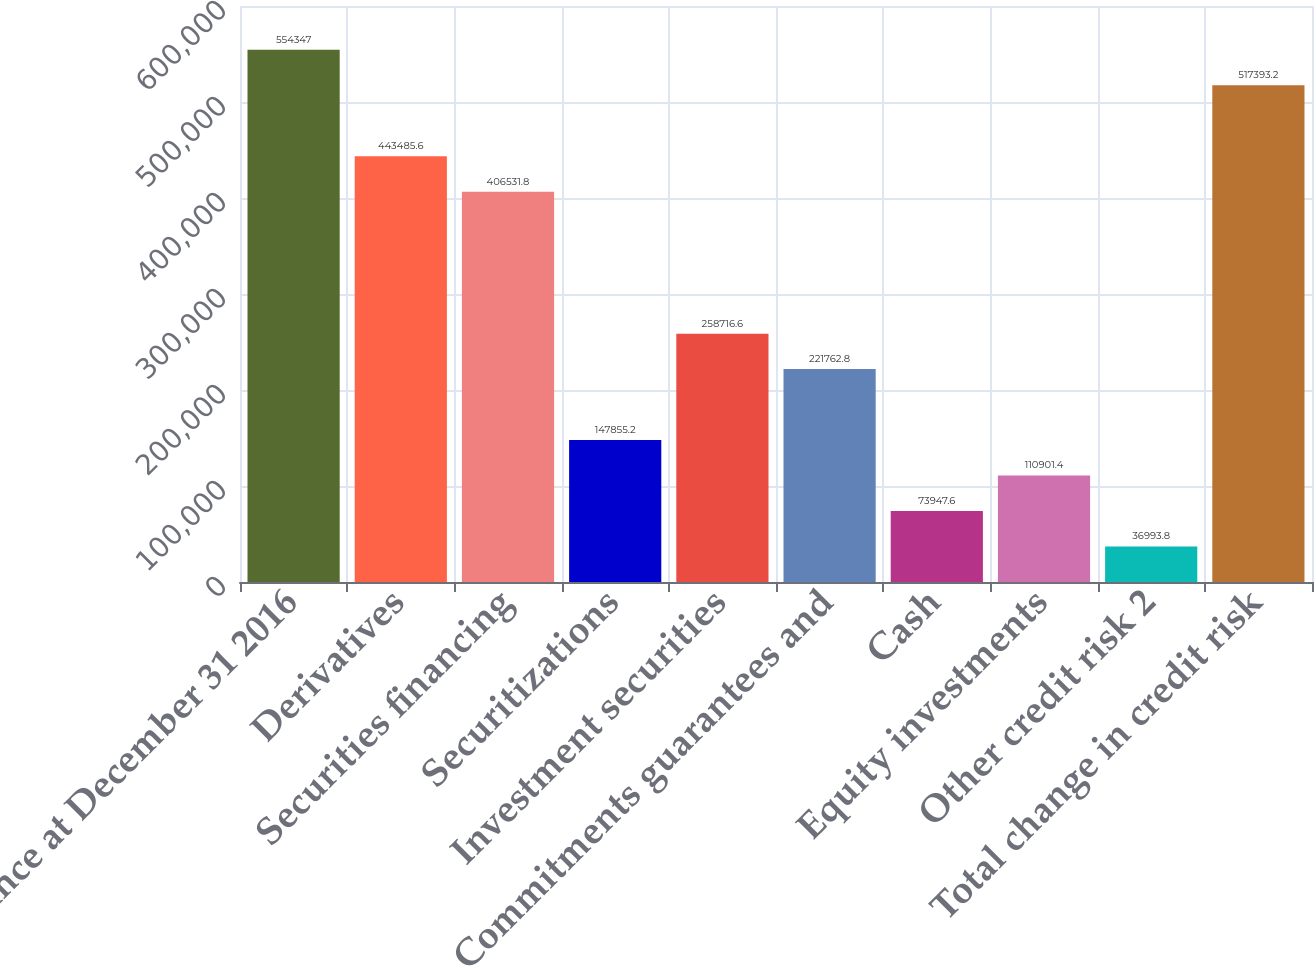Convert chart to OTSL. <chart><loc_0><loc_0><loc_500><loc_500><bar_chart><fcel>Balance at December 31 2016<fcel>Derivatives<fcel>Securities financing<fcel>Securitizations<fcel>Investment securities<fcel>Commitments guarantees and<fcel>Cash<fcel>Equity investments<fcel>Other credit risk 2<fcel>Total change in credit risk<nl><fcel>554347<fcel>443486<fcel>406532<fcel>147855<fcel>258717<fcel>221763<fcel>73947.6<fcel>110901<fcel>36993.8<fcel>517393<nl></chart> 